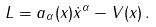<formula> <loc_0><loc_0><loc_500><loc_500>L = a _ { \alpha } ( x ) { \dot { x } } ^ { \alpha } - V ( x ) \, .</formula> 